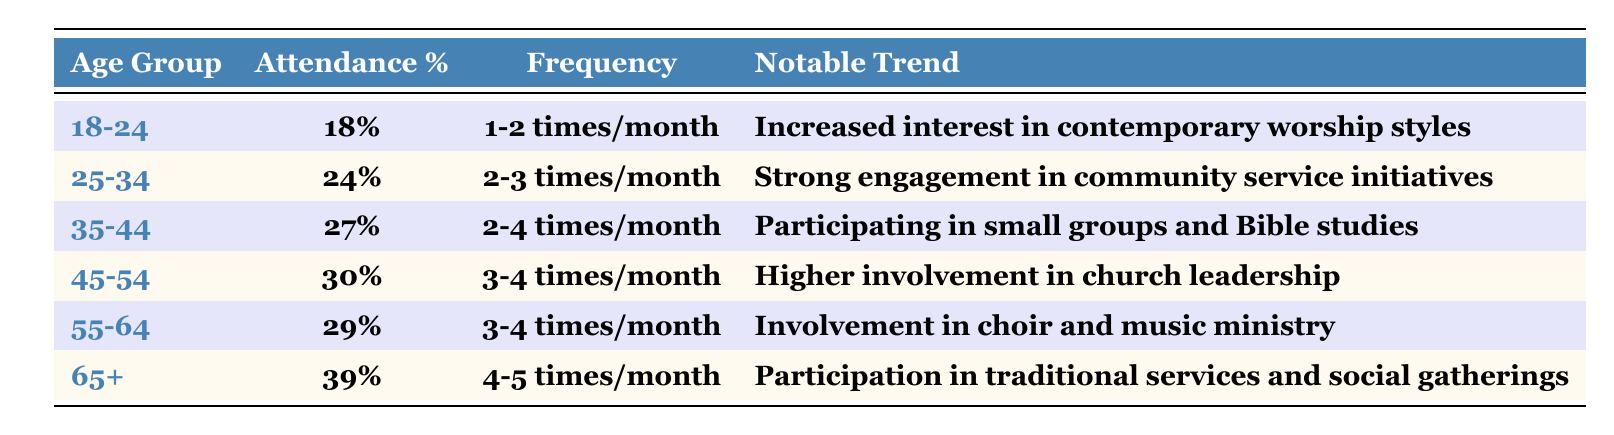What is the attendance percentage for the age group 45-54? According to the table, the attendance percentage for the age group 45-54 is listed directly in the second column of that row. It states 30%.
Answer: 30% Which age group has the highest average attendance frequency? The age group 65+ has the highest average attendance frequency, recorded as 4-5 times per month, which can be found in the third column of the respective row.
Answer: 65+ What is the notable trend for the age group 35-44? Looking at the table, the notable trend for the age group 35-44 is "Participating in small groups and Bible studies," as indicated in the last column of that row.
Answer: Participating in small groups and Bible studies How many age groups have an attendance percentage of 30% or higher? By reviewing the attendance percentages listed, the age groups 45-54 (30%), 55-64 (29%), and 65+ (39%) are the only ones with percentages at or above 30%. Therefore, there are 3 age groups that meet this criterion.
Answer: 2 What is the difference in attendance percentage between the age groups 25-34 and 55-64? The attendance percentage for 25-34 is 24% and for 55-64 is 29%. To find the difference, subtract 24 from 29, which equals 5%.
Answer: 5% Is there a notable trend associated with both the 18-24 and 65+ age groups? Yes, by examining the table, we can see that the 18-24 age group has the trend of increasing interest in contemporary worship styles, and the 65+ group participates in traditional services and social gatherings. Thus, both age groups have distinct notable trends.
Answer: Yes Which age group participates in community service initiatives, and how does this group's attendance frequency compare to that of the 45-54 age group? The age group 25-34 is noted for strong engagement in community service initiatives, with an attendance frequency of 2-3 times per month. The 45-54 age group's frequency is higher at 3-4 times per month. Therefore, the 25-34 group has lower attendance frequency compared to the 45-54 group.
Answer: Lower If we combine the attendance percentages for all age groups, what is the total? To find the total, we sum the attendance percentages: 18% + 24% + 27% + 30% + 29% + 39% = 167%. Thus, the total attendance percentage for all age groups combined is 167%.
Answer: 167% What percentage of the age group 65+ participates in traditional services and social gatherings? The table indicates that 39% of the age group 65+ participates in traditional services and social gatherings, found directly in the attendance percentage column for that age group.
Answer: 39% 